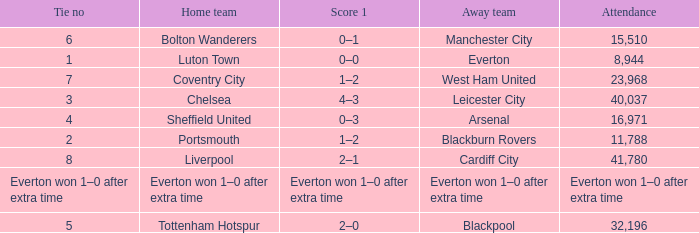What home team had an attendance record of 16,971? Sheffield United. 